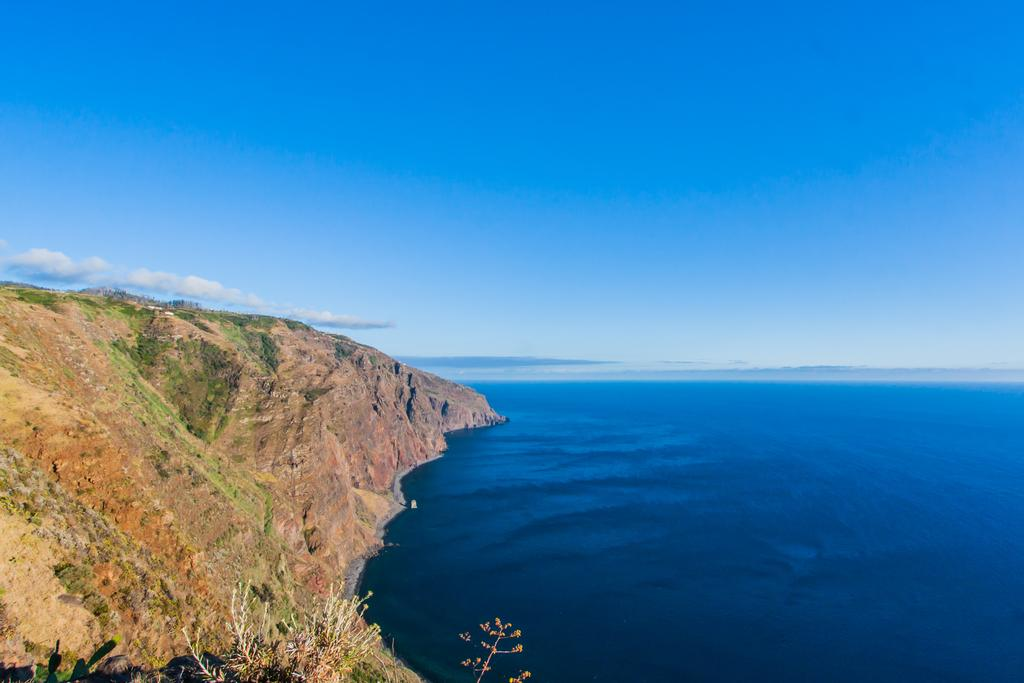What can be seen in the sky in the image? The sky with clouds is visible in the image. What type of natural body of water is present in the image? There is an ocean in the image. What type of vegetation is present in the image? There are plants in the image. What type of landform can be seen in the image? There is a hill in the image. How many bikes are parked on the hill in the image? There are no bikes present in the image. Is there a camp set up near the ocean in the image? There is no camp present in the image. 